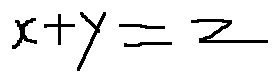<formula> <loc_0><loc_0><loc_500><loc_500>x + y = z</formula> 